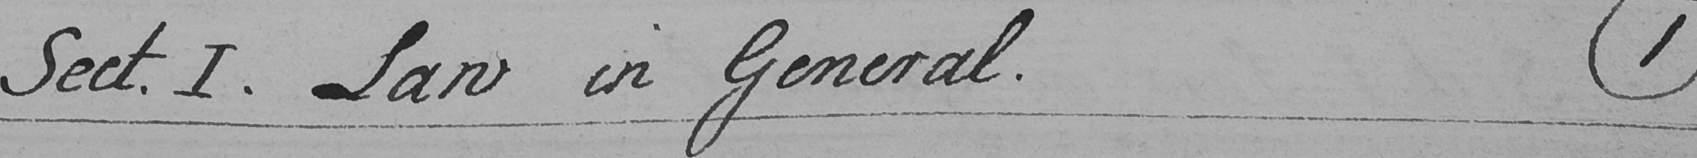What does this handwritten line say? Sect . I . Law in General .  ( 1 